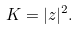<formula> <loc_0><loc_0><loc_500><loc_500>K = | z | ^ { 2 } .</formula> 